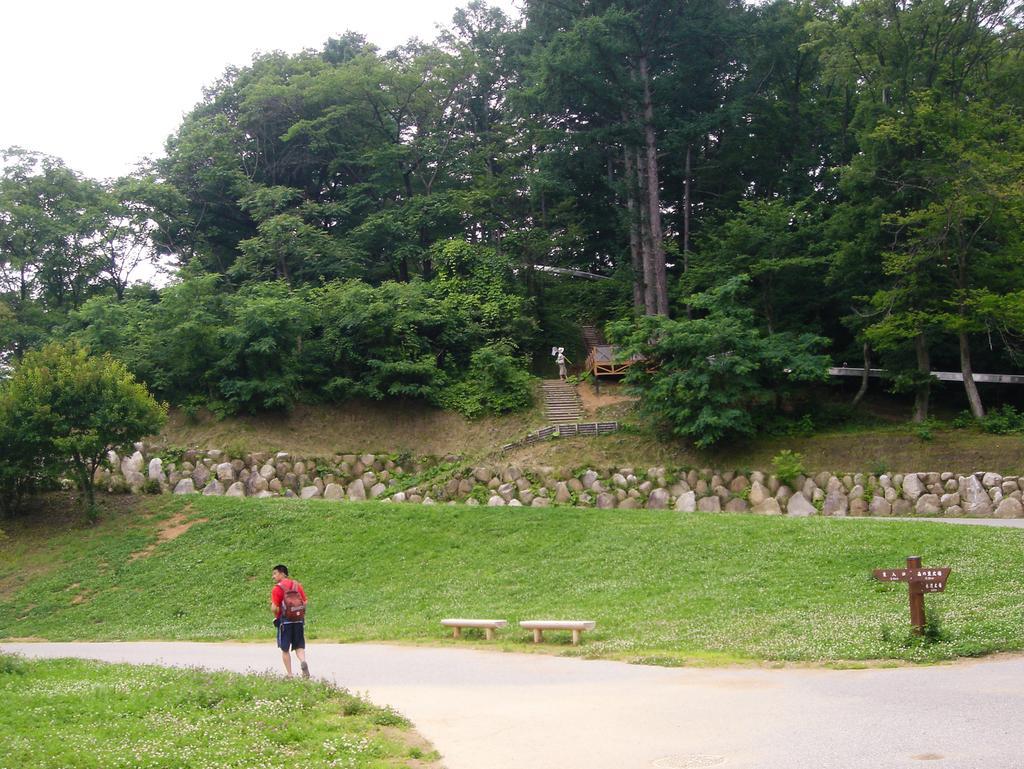How would you summarize this image in a sentence or two? In this image, we can see a person wearing a bag and in the background, there are trees, stairs, rocks, benches, a pole and there is a shed and an object. At the bottom, there is a road and at the top, there is sky. 